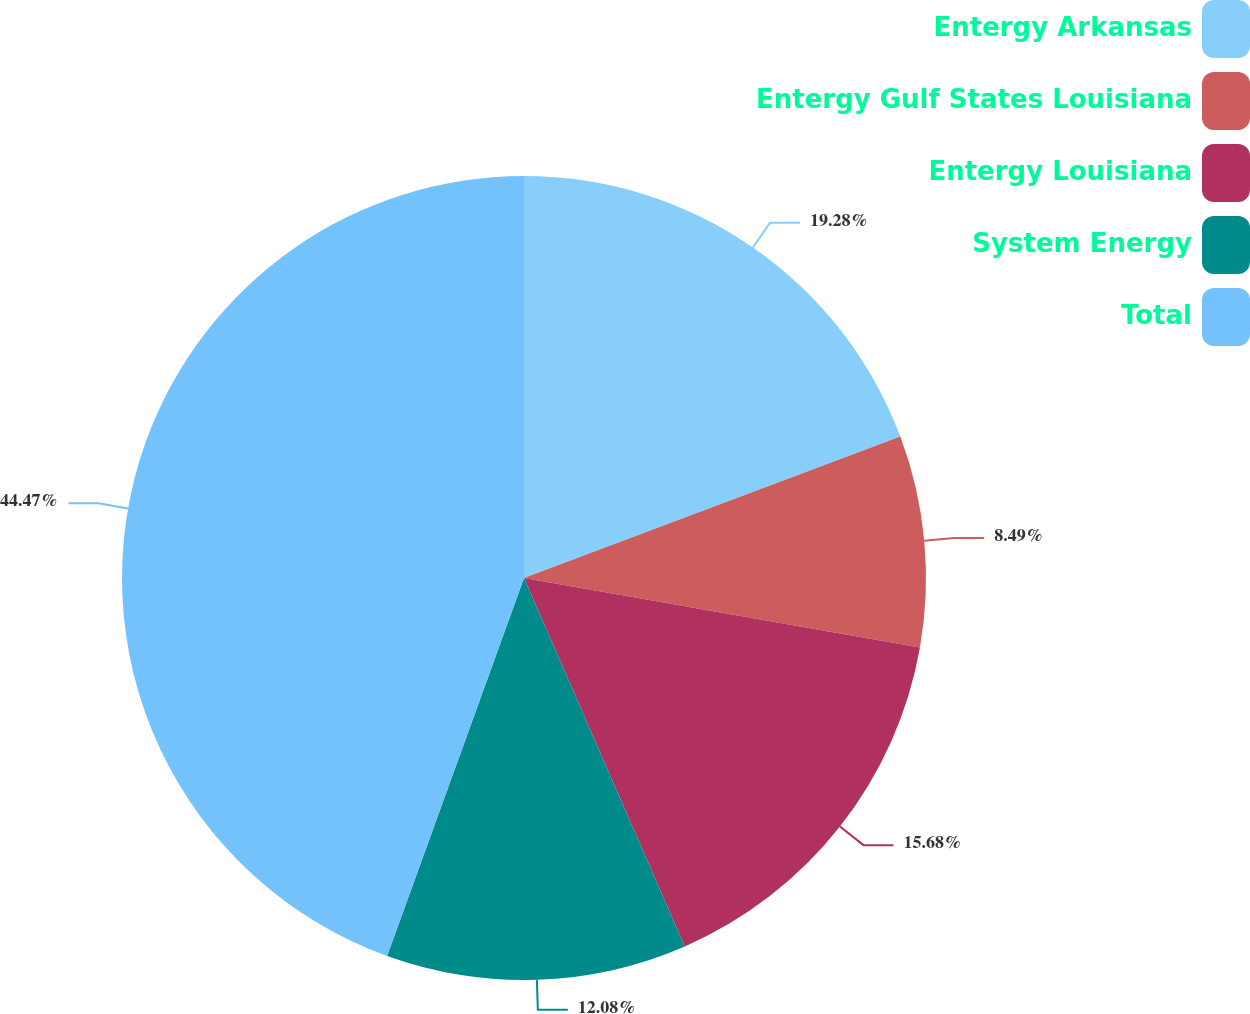Convert chart to OTSL. <chart><loc_0><loc_0><loc_500><loc_500><pie_chart><fcel>Entergy Arkansas<fcel>Entergy Gulf States Louisiana<fcel>Entergy Louisiana<fcel>System Energy<fcel>Total<nl><fcel>19.28%<fcel>8.49%<fcel>15.68%<fcel>12.08%<fcel>44.47%<nl></chart> 